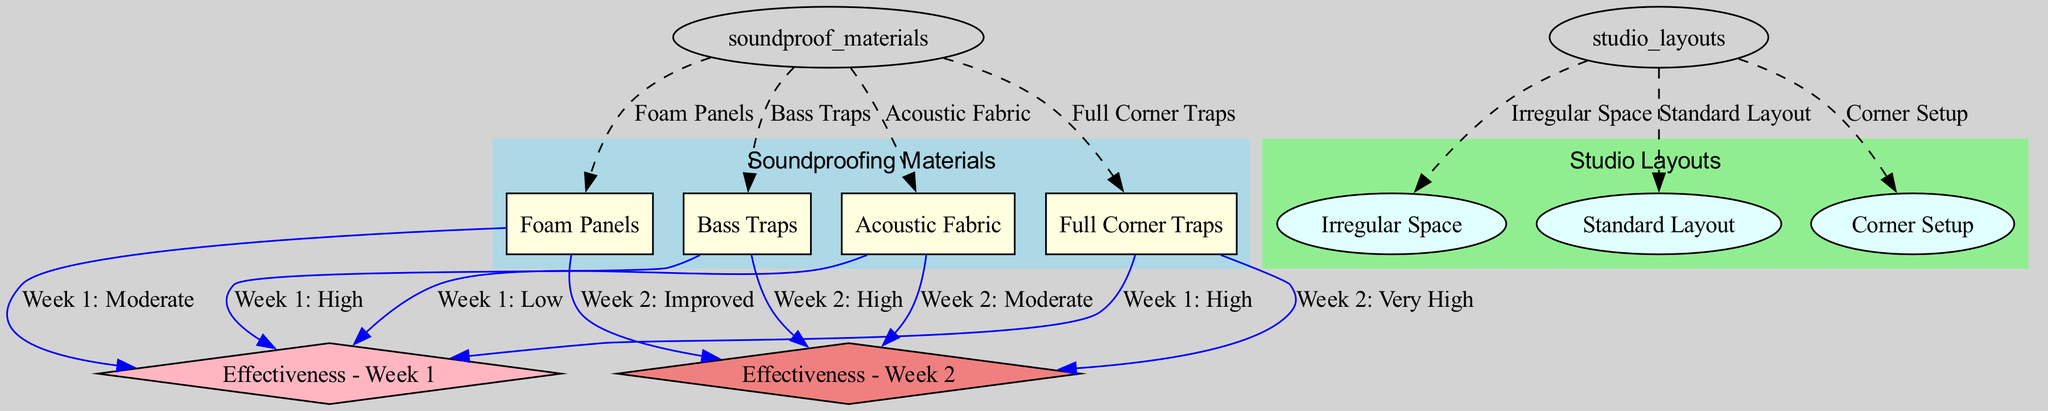What are the four soundproofing materials listed? The diagram explicitly lists four soundproofing materials: Foam Panels, Bass Traps, Acoustic Fabric, and Full Corner Traps. These materials are connected to the node labeled "Soundproofing Materials".
Answer: Foam Panels, Bass Traps, Acoustic Fabric, Full Corner Traps What is the effectiveness of bass traps in week 1? According to the diagram, the effectiveness of bass traps in week 1 is described as "High". This information is derived from the edge connecting the bass traps to the effectiveness for week 1.
Answer: High Which studio layout has three types of indicated materials? The "Irregular Space" layout is linked to multiple materials in the diagram. However, it actually doesn’t specify any materials directly under it; instead, it connects to the "Soundproofing Materials". Therefore, the more accurate observation is that the "Standard Layout" and "Corner Setup" layouts are the only ones potentially indicating effectiveness against several materials.
Answer: Standard Layout What is the effectiveness of foam panels in week 2? The edge from foam panels to "Effectiveness - Week 2" indicates that its effectiveness is labeled as "Improved". This means there has been a noticeable enhancement in soundproofing with foam panels by the second week.
Answer: Improved Which studio layout connects to corner setup? The diagram shows that "Corner Setup" is directly linked to the "Studio Layouts" node. This indicates it is recognized as one of the layouts available for the soundproofing materials.
Answer: Corner Setup What is the effectiveness of full corner traps in week 2? The effectiveness of full corner traps in week 2 is shown as "Very High". This information can be traced back through the edge in the diagram that presents its effectiveness for that period.
Answer: Very High How many total nodes are in the diagram? The total count of nodes in the diagram includes soundproofing materials, studio layouts, and weekly effectiveness indicators, leading to a total of 11 nodes. This is confirmed by counting each distinct element in the "nodes" section of the data.
Answer: 11 How does acoustic fabric's effectiveness change from week 1 to week 2? The effectiveness of acoustic fabric shifts from "Low" in week 1 to "Moderate" in week 2, showcasing an improvement over time. The diagram connects these two effectiveness nodes to the acoustic fabric node, demonstrating the progression in its soundproofing capability.
Answer: Low to Moderate 